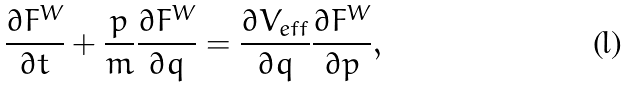Convert formula to latex. <formula><loc_0><loc_0><loc_500><loc_500>\frac { \partial F ^ { W } } { \partial t } + \frac { p } { m } \frac { \partial F ^ { W } } { \partial q } = \frac { \partial V _ { e f f } } { \partial q } \frac { \partial F ^ { W } } { \partial p } ,</formula> 